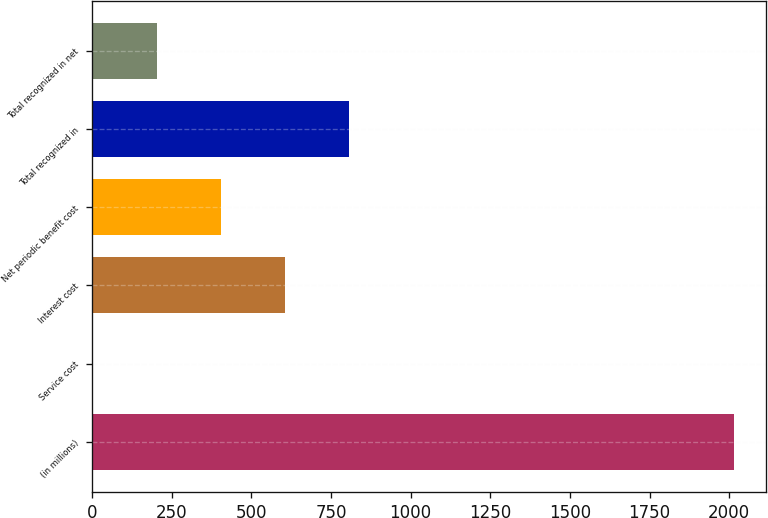Convert chart to OTSL. <chart><loc_0><loc_0><loc_500><loc_500><bar_chart><fcel>(in millions)<fcel>Service cost<fcel>Interest cost<fcel>Net periodic benefit cost<fcel>Total recognized in<fcel>Total recognized in net<nl><fcel>2016<fcel>2<fcel>606.2<fcel>404.8<fcel>807.6<fcel>203.4<nl></chart> 